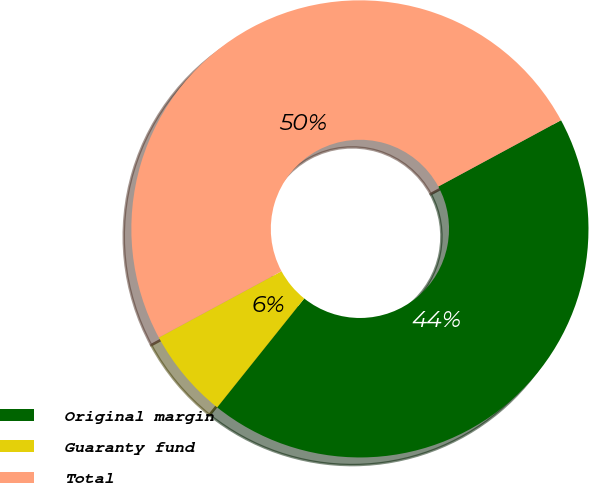Convert chart to OTSL. <chart><loc_0><loc_0><loc_500><loc_500><pie_chart><fcel>Original margin<fcel>Guaranty fund<fcel>Total<nl><fcel>43.62%<fcel>6.38%<fcel>50.0%<nl></chart> 